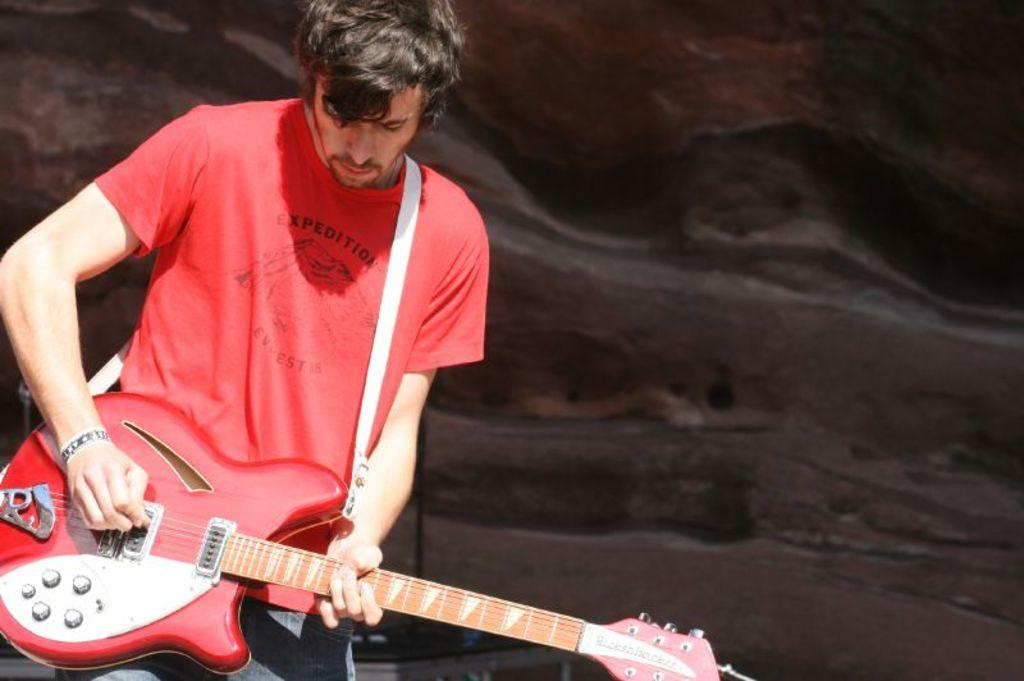What is the man doing on the left side of the image? The man is standing on the left side of the image and playing the guitar. What is the man holding in the image? The man is holding a guitar in the image. What can be seen in the background of the image? The background of the image is black in color. How many cent bells are hanging from the man's neck in the image? There are no bells or cent bells present in the image. What type of food is the man cooking in the image? There is no cooking or food preparation depicted in the image; the man is playing the guitar. 